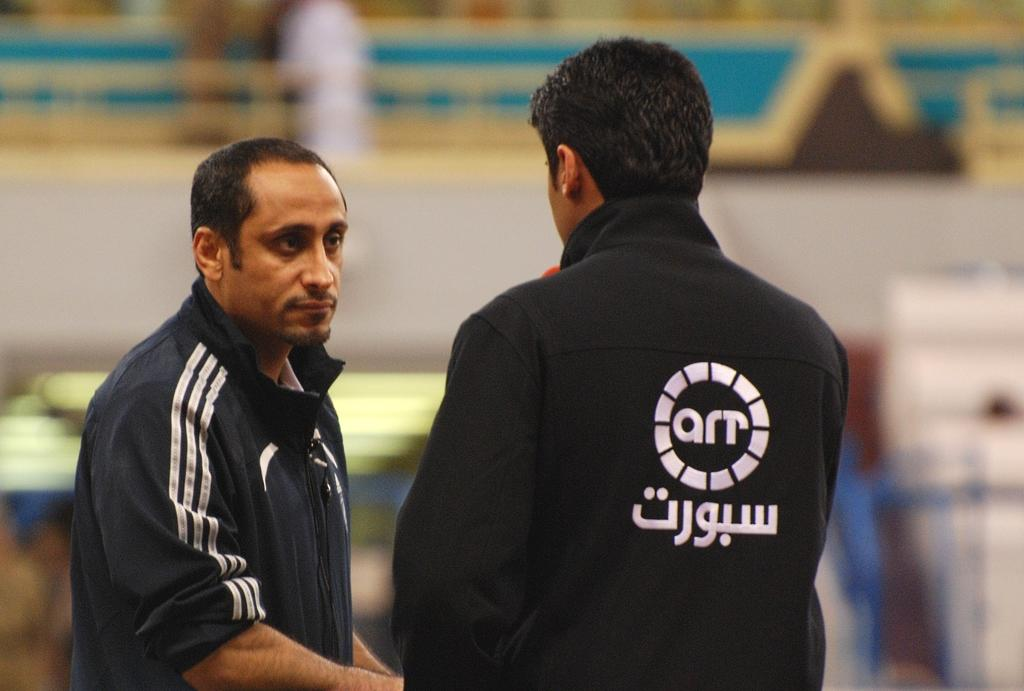<image>
Create a compact narrative representing the image presented. The two people here are working for a company called art 